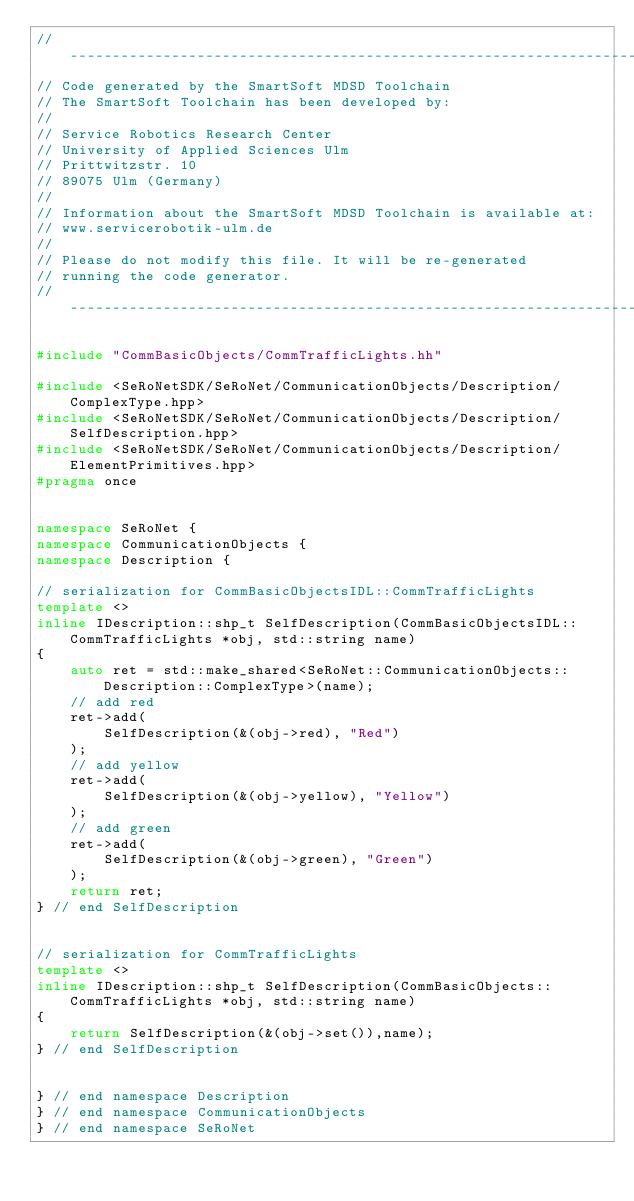<code> <loc_0><loc_0><loc_500><loc_500><_C++_>//--------------------------------------------------------------------------
// Code generated by the SmartSoft MDSD Toolchain
// The SmartSoft Toolchain has been developed by:
//  
// Service Robotics Research Center
// University of Applied Sciences Ulm
// Prittwitzstr. 10
// 89075 Ulm (Germany)
//
// Information about the SmartSoft MDSD Toolchain is available at:
// www.servicerobotik-ulm.de
//
// Please do not modify this file. It will be re-generated
// running the code generator.
//--------------------------------------------------------------------------

#include "CommBasicObjects/CommTrafficLights.hh"

#include <SeRoNetSDK/SeRoNet/CommunicationObjects/Description/ComplexType.hpp>
#include <SeRoNetSDK/SeRoNet/CommunicationObjects/Description/SelfDescription.hpp>
#include <SeRoNetSDK/SeRoNet/CommunicationObjects/Description/ElementPrimitives.hpp>
#pragma once


namespace SeRoNet {
namespace CommunicationObjects {
namespace Description {
	
// serialization for CommBasicObjectsIDL::CommTrafficLights
template <>
inline IDescription::shp_t SelfDescription(CommBasicObjectsIDL::CommTrafficLights *obj, std::string name)
{
	auto ret = std::make_shared<SeRoNet::CommunicationObjects::Description::ComplexType>(name);
	// add red
	ret->add(
		SelfDescription(&(obj->red), "Red")
	);
	// add yellow
	ret->add(
		SelfDescription(&(obj->yellow), "Yellow")
	);
	// add green
	ret->add(
		SelfDescription(&(obj->green), "Green")
	);
	return ret;
} // end SelfDescription


// serialization for CommTrafficLights
template <>
inline IDescription::shp_t SelfDescription(CommBasicObjects::CommTrafficLights *obj, std::string name)
{
	return SelfDescription(&(obj->set()),name); 
} // end SelfDescription


} // end namespace Description
} // end namespace CommunicationObjects
} // end namespace SeRoNet
</code> 